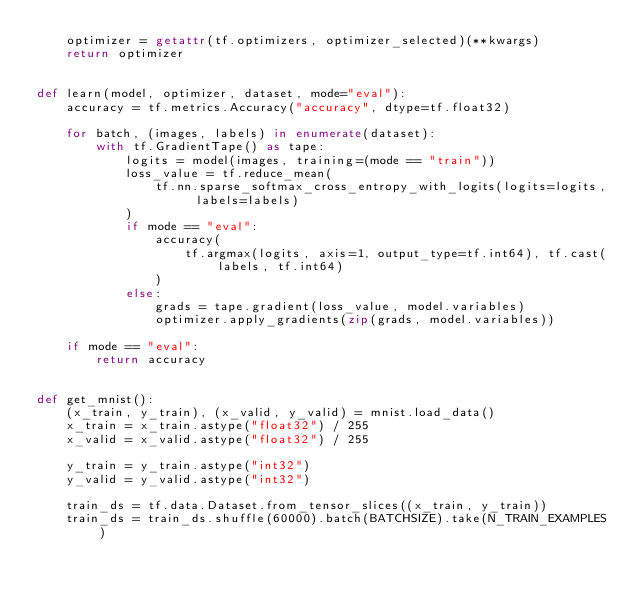Convert code to text. <code><loc_0><loc_0><loc_500><loc_500><_Python_>    optimizer = getattr(tf.optimizers, optimizer_selected)(**kwargs)
    return optimizer


def learn(model, optimizer, dataset, mode="eval"):
    accuracy = tf.metrics.Accuracy("accuracy", dtype=tf.float32)

    for batch, (images, labels) in enumerate(dataset):
        with tf.GradientTape() as tape:
            logits = model(images, training=(mode == "train"))
            loss_value = tf.reduce_mean(
                tf.nn.sparse_softmax_cross_entropy_with_logits(logits=logits, labels=labels)
            )
            if mode == "eval":
                accuracy(
                    tf.argmax(logits, axis=1, output_type=tf.int64), tf.cast(labels, tf.int64)
                )
            else:
                grads = tape.gradient(loss_value, model.variables)
                optimizer.apply_gradients(zip(grads, model.variables))

    if mode == "eval":
        return accuracy


def get_mnist():
    (x_train, y_train), (x_valid, y_valid) = mnist.load_data()
    x_train = x_train.astype("float32") / 255
    x_valid = x_valid.astype("float32") / 255

    y_train = y_train.astype("int32")
    y_valid = y_valid.astype("int32")

    train_ds = tf.data.Dataset.from_tensor_slices((x_train, y_train))
    train_ds = train_ds.shuffle(60000).batch(BATCHSIZE).take(N_TRAIN_EXAMPLES)
</code> 